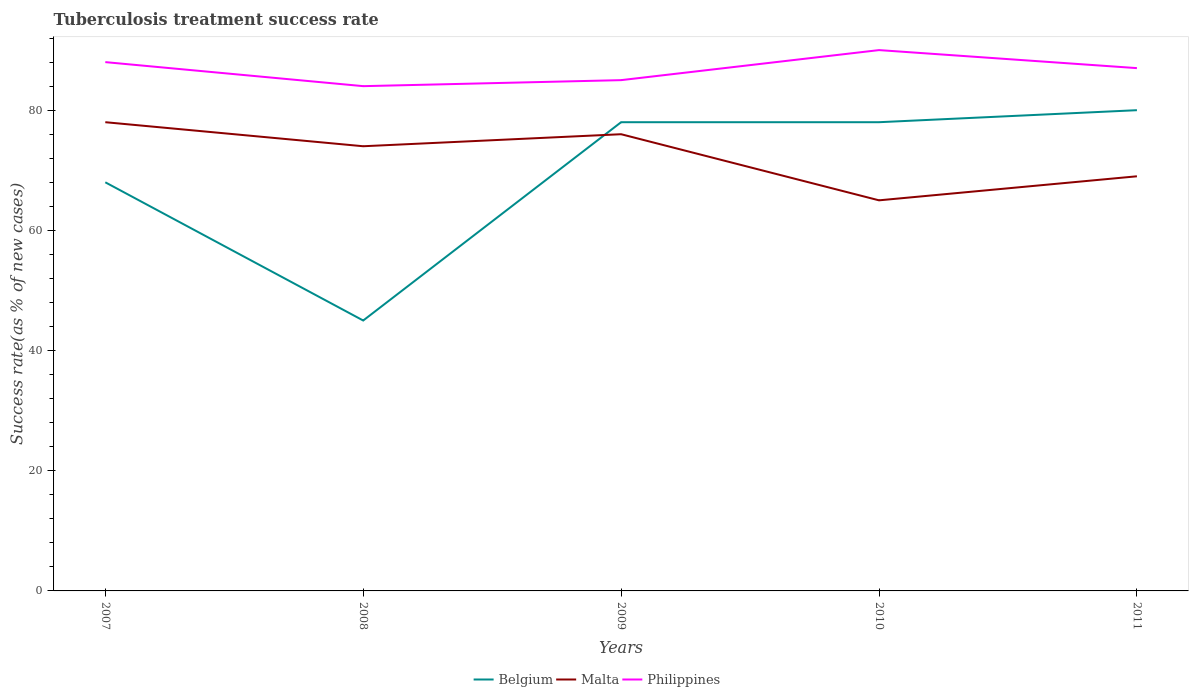How many different coloured lines are there?
Your answer should be compact. 3. What is the total tuberculosis treatment success rate in Philippines in the graph?
Provide a succinct answer. -5. What is the difference between the highest and the second highest tuberculosis treatment success rate in Malta?
Give a very brief answer. 13. Are the values on the major ticks of Y-axis written in scientific E-notation?
Give a very brief answer. No. Where does the legend appear in the graph?
Offer a very short reply. Bottom center. How many legend labels are there?
Your response must be concise. 3. What is the title of the graph?
Provide a succinct answer. Tuberculosis treatment success rate. What is the label or title of the Y-axis?
Your response must be concise. Success rate(as % of new cases). What is the Success rate(as % of new cases) of Belgium in 2007?
Offer a very short reply. 68. What is the Success rate(as % of new cases) of Philippines in 2007?
Provide a succinct answer. 88. What is the Success rate(as % of new cases) of Belgium in 2008?
Ensure brevity in your answer.  45. What is the Success rate(as % of new cases) of Malta in 2008?
Ensure brevity in your answer.  74. What is the Success rate(as % of new cases) in Malta in 2010?
Ensure brevity in your answer.  65. What is the Success rate(as % of new cases) in Philippines in 2010?
Keep it short and to the point. 90. What is the Success rate(as % of new cases) of Belgium in 2011?
Ensure brevity in your answer.  80. What is the Success rate(as % of new cases) of Malta in 2011?
Ensure brevity in your answer.  69. Across all years, what is the maximum Success rate(as % of new cases) in Belgium?
Ensure brevity in your answer.  80. Across all years, what is the minimum Success rate(as % of new cases) in Belgium?
Give a very brief answer. 45. Across all years, what is the minimum Success rate(as % of new cases) of Malta?
Provide a short and direct response. 65. Across all years, what is the minimum Success rate(as % of new cases) in Philippines?
Provide a short and direct response. 84. What is the total Success rate(as % of new cases) of Belgium in the graph?
Your answer should be very brief. 349. What is the total Success rate(as % of new cases) of Malta in the graph?
Offer a very short reply. 362. What is the total Success rate(as % of new cases) in Philippines in the graph?
Provide a succinct answer. 434. What is the difference between the Success rate(as % of new cases) of Malta in 2007 and that in 2008?
Your answer should be very brief. 4. What is the difference between the Success rate(as % of new cases) in Belgium in 2007 and that in 2009?
Ensure brevity in your answer.  -10. What is the difference between the Success rate(as % of new cases) in Philippines in 2007 and that in 2009?
Provide a short and direct response. 3. What is the difference between the Success rate(as % of new cases) of Malta in 2007 and that in 2010?
Provide a succinct answer. 13. What is the difference between the Success rate(as % of new cases) in Philippines in 2007 and that in 2010?
Your response must be concise. -2. What is the difference between the Success rate(as % of new cases) of Belgium in 2008 and that in 2009?
Offer a very short reply. -33. What is the difference between the Success rate(as % of new cases) in Malta in 2008 and that in 2009?
Provide a succinct answer. -2. What is the difference between the Success rate(as % of new cases) in Philippines in 2008 and that in 2009?
Ensure brevity in your answer.  -1. What is the difference between the Success rate(as % of new cases) in Belgium in 2008 and that in 2010?
Your answer should be compact. -33. What is the difference between the Success rate(as % of new cases) of Malta in 2008 and that in 2010?
Offer a very short reply. 9. What is the difference between the Success rate(as % of new cases) in Philippines in 2008 and that in 2010?
Give a very brief answer. -6. What is the difference between the Success rate(as % of new cases) in Belgium in 2008 and that in 2011?
Offer a very short reply. -35. What is the difference between the Success rate(as % of new cases) of Malta in 2008 and that in 2011?
Offer a very short reply. 5. What is the difference between the Success rate(as % of new cases) of Belgium in 2009 and that in 2010?
Keep it short and to the point. 0. What is the difference between the Success rate(as % of new cases) of Malta in 2009 and that in 2011?
Keep it short and to the point. 7. What is the difference between the Success rate(as % of new cases) in Philippines in 2009 and that in 2011?
Your answer should be very brief. -2. What is the difference between the Success rate(as % of new cases) of Belgium in 2010 and that in 2011?
Offer a terse response. -2. What is the difference between the Success rate(as % of new cases) in Malta in 2010 and that in 2011?
Give a very brief answer. -4. What is the difference between the Success rate(as % of new cases) in Malta in 2007 and the Success rate(as % of new cases) in Philippines in 2009?
Keep it short and to the point. -7. What is the difference between the Success rate(as % of new cases) of Belgium in 2007 and the Success rate(as % of new cases) of Malta in 2010?
Make the answer very short. 3. What is the difference between the Success rate(as % of new cases) of Belgium in 2007 and the Success rate(as % of new cases) of Philippines in 2010?
Your answer should be compact. -22. What is the difference between the Success rate(as % of new cases) of Malta in 2007 and the Success rate(as % of new cases) of Philippines in 2010?
Your answer should be very brief. -12. What is the difference between the Success rate(as % of new cases) in Belgium in 2007 and the Success rate(as % of new cases) in Malta in 2011?
Give a very brief answer. -1. What is the difference between the Success rate(as % of new cases) of Belgium in 2008 and the Success rate(as % of new cases) of Malta in 2009?
Your answer should be very brief. -31. What is the difference between the Success rate(as % of new cases) of Belgium in 2008 and the Success rate(as % of new cases) of Philippines in 2009?
Keep it short and to the point. -40. What is the difference between the Success rate(as % of new cases) in Malta in 2008 and the Success rate(as % of new cases) in Philippines in 2009?
Your answer should be very brief. -11. What is the difference between the Success rate(as % of new cases) in Belgium in 2008 and the Success rate(as % of new cases) in Malta in 2010?
Your answer should be compact. -20. What is the difference between the Success rate(as % of new cases) in Belgium in 2008 and the Success rate(as % of new cases) in Philippines in 2010?
Make the answer very short. -45. What is the difference between the Success rate(as % of new cases) in Malta in 2008 and the Success rate(as % of new cases) in Philippines in 2010?
Provide a short and direct response. -16. What is the difference between the Success rate(as % of new cases) in Belgium in 2008 and the Success rate(as % of new cases) in Philippines in 2011?
Your answer should be compact. -42. What is the difference between the Success rate(as % of new cases) of Belgium in 2009 and the Success rate(as % of new cases) of Philippines in 2010?
Make the answer very short. -12. What is the difference between the Success rate(as % of new cases) in Malta in 2009 and the Success rate(as % of new cases) in Philippines in 2010?
Provide a succinct answer. -14. What is the difference between the Success rate(as % of new cases) of Belgium in 2009 and the Success rate(as % of new cases) of Malta in 2011?
Provide a short and direct response. 9. What is the difference between the Success rate(as % of new cases) in Belgium in 2009 and the Success rate(as % of new cases) in Philippines in 2011?
Provide a succinct answer. -9. What is the average Success rate(as % of new cases) of Belgium per year?
Ensure brevity in your answer.  69.8. What is the average Success rate(as % of new cases) in Malta per year?
Your response must be concise. 72.4. What is the average Success rate(as % of new cases) in Philippines per year?
Offer a terse response. 86.8. In the year 2007, what is the difference between the Success rate(as % of new cases) of Belgium and Success rate(as % of new cases) of Philippines?
Provide a succinct answer. -20. In the year 2008, what is the difference between the Success rate(as % of new cases) in Belgium and Success rate(as % of new cases) in Malta?
Provide a short and direct response. -29. In the year 2008, what is the difference between the Success rate(as % of new cases) in Belgium and Success rate(as % of new cases) in Philippines?
Make the answer very short. -39. In the year 2008, what is the difference between the Success rate(as % of new cases) of Malta and Success rate(as % of new cases) of Philippines?
Ensure brevity in your answer.  -10. In the year 2010, what is the difference between the Success rate(as % of new cases) in Belgium and Success rate(as % of new cases) in Malta?
Your answer should be compact. 13. In the year 2011, what is the difference between the Success rate(as % of new cases) in Belgium and Success rate(as % of new cases) in Malta?
Offer a very short reply. 11. In the year 2011, what is the difference between the Success rate(as % of new cases) of Malta and Success rate(as % of new cases) of Philippines?
Ensure brevity in your answer.  -18. What is the ratio of the Success rate(as % of new cases) of Belgium in 2007 to that in 2008?
Provide a succinct answer. 1.51. What is the ratio of the Success rate(as % of new cases) of Malta in 2007 to that in 2008?
Offer a terse response. 1.05. What is the ratio of the Success rate(as % of new cases) of Philippines in 2007 to that in 2008?
Offer a very short reply. 1.05. What is the ratio of the Success rate(as % of new cases) in Belgium in 2007 to that in 2009?
Make the answer very short. 0.87. What is the ratio of the Success rate(as % of new cases) in Malta in 2007 to that in 2009?
Provide a succinct answer. 1.03. What is the ratio of the Success rate(as % of new cases) of Philippines in 2007 to that in 2009?
Offer a terse response. 1.04. What is the ratio of the Success rate(as % of new cases) of Belgium in 2007 to that in 2010?
Your answer should be compact. 0.87. What is the ratio of the Success rate(as % of new cases) in Philippines in 2007 to that in 2010?
Give a very brief answer. 0.98. What is the ratio of the Success rate(as % of new cases) of Malta in 2007 to that in 2011?
Give a very brief answer. 1.13. What is the ratio of the Success rate(as % of new cases) in Philippines in 2007 to that in 2011?
Offer a terse response. 1.01. What is the ratio of the Success rate(as % of new cases) in Belgium in 2008 to that in 2009?
Your answer should be compact. 0.58. What is the ratio of the Success rate(as % of new cases) in Malta in 2008 to that in 2009?
Keep it short and to the point. 0.97. What is the ratio of the Success rate(as % of new cases) of Belgium in 2008 to that in 2010?
Offer a terse response. 0.58. What is the ratio of the Success rate(as % of new cases) in Malta in 2008 to that in 2010?
Ensure brevity in your answer.  1.14. What is the ratio of the Success rate(as % of new cases) in Philippines in 2008 to that in 2010?
Your answer should be compact. 0.93. What is the ratio of the Success rate(as % of new cases) in Belgium in 2008 to that in 2011?
Your response must be concise. 0.56. What is the ratio of the Success rate(as % of new cases) in Malta in 2008 to that in 2011?
Your answer should be very brief. 1.07. What is the ratio of the Success rate(as % of new cases) in Philippines in 2008 to that in 2011?
Offer a very short reply. 0.97. What is the ratio of the Success rate(as % of new cases) in Malta in 2009 to that in 2010?
Your response must be concise. 1.17. What is the ratio of the Success rate(as % of new cases) in Belgium in 2009 to that in 2011?
Your answer should be compact. 0.97. What is the ratio of the Success rate(as % of new cases) in Malta in 2009 to that in 2011?
Keep it short and to the point. 1.1. What is the ratio of the Success rate(as % of new cases) in Philippines in 2009 to that in 2011?
Ensure brevity in your answer.  0.98. What is the ratio of the Success rate(as % of new cases) of Malta in 2010 to that in 2011?
Provide a succinct answer. 0.94. What is the ratio of the Success rate(as % of new cases) of Philippines in 2010 to that in 2011?
Provide a succinct answer. 1.03. What is the difference between the highest and the second highest Success rate(as % of new cases) of Belgium?
Your answer should be very brief. 2. What is the difference between the highest and the second highest Success rate(as % of new cases) of Malta?
Ensure brevity in your answer.  2. 